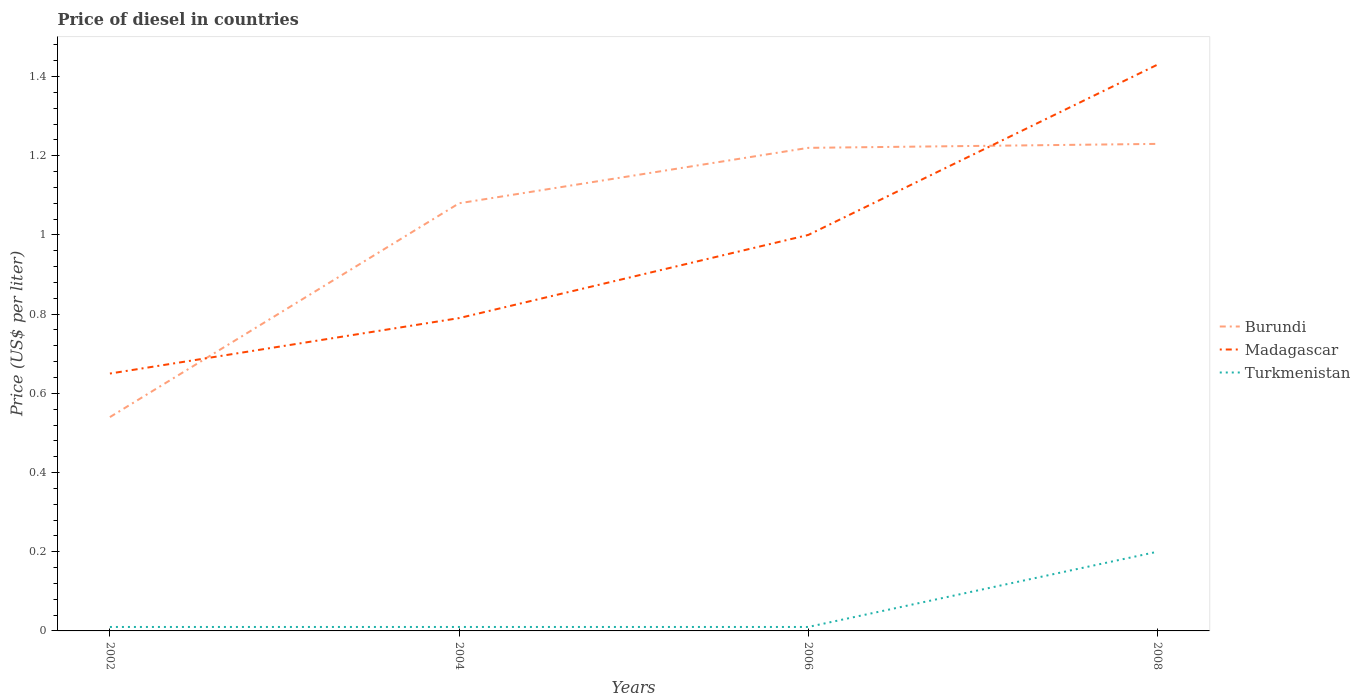Is the number of lines equal to the number of legend labels?
Provide a succinct answer. Yes. Across all years, what is the maximum price of diesel in Burundi?
Give a very brief answer. 0.54. In which year was the price of diesel in Madagascar maximum?
Make the answer very short. 2002. What is the total price of diesel in Burundi in the graph?
Offer a very short reply. -0.14. What is the difference between the highest and the second highest price of diesel in Burundi?
Make the answer very short. 0.69. What is the difference between the highest and the lowest price of diesel in Madagascar?
Offer a very short reply. 2. How many lines are there?
Ensure brevity in your answer.  3. How many years are there in the graph?
Offer a terse response. 4. Does the graph contain any zero values?
Provide a succinct answer. No. What is the title of the graph?
Offer a very short reply. Price of diesel in countries. What is the label or title of the Y-axis?
Your response must be concise. Price (US$ per liter). What is the Price (US$ per liter) in Burundi in 2002?
Keep it short and to the point. 0.54. What is the Price (US$ per liter) in Madagascar in 2002?
Provide a short and direct response. 0.65. What is the Price (US$ per liter) in Turkmenistan in 2002?
Ensure brevity in your answer.  0.01. What is the Price (US$ per liter) in Burundi in 2004?
Your response must be concise. 1.08. What is the Price (US$ per liter) in Madagascar in 2004?
Provide a short and direct response. 0.79. What is the Price (US$ per liter) in Turkmenistan in 2004?
Offer a terse response. 0.01. What is the Price (US$ per liter) of Burundi in 2006?
Give a very brief answer. 1.22. What is the Price (US$ per liter) of Madagascar in 2006?
Your response must be concise. 1. What is the Price (US$ per liter) in Burundi in 2008?
Your response must be concise. 1.23. What is the Price (US$ per liter) in Madagascar in 2008?
Give a very brief answer. 1.43. Across all years, what is the maximum Price (US$ per liter) in Burundi?
Offer a very short reply. 1.23. Across all years, what is the maximum Price (US$ per liter) in Madagascar?
Your response must be concise. 1.43. Across all years, what is the maximum Price (US$ per liter) in Turkmenistan?
Offer a terse response. 0.2. Across all years, what is the minimum Price (US$ per liter) of Burundi?
Provide a succinct answer. 0.54. Across all years, what is the minimum Price (US$ per liter) in Madagascar?
Offer a very short reply. 0.65. What is the total Price (US$ per liter) in Burundi in the graph?
Make the answer very short. 4.07. What is the total Price (US$ per liter) of Madagascar in the graph?
Ensure brevity in your answer.  3.87. What is the total Price (US$ per liter) of Turkmenistan in the graph?
Make the answer very short. 0.23. What is the difference between the Price (US$ per liter) in Burundi in 2002 and that in 2004?
Provide a short and direct response. -0.54. What is the difference between the Price (US$ per liter) of Madagascar in 2002 and that in 2004?
Keep it short and to the point. -0.14. What is the difference between the Price (US$ per liter) of Burundi in 2002 and that in 2006?
Your answer should be compact. -0.68. What is the difference between the Price (US$ per liter) of Madagascar in 2002 and that in 2006?
Make the answer very short. -0.35. What is the difference between the Price (US$ per liter) of Turkmenistan in 2002 and that in 2006?
Your response must be concise. 0. What is the difference between the Price (US$ per liter) in Burundi in 2002 and that in 2008?
Provide a succinct answer. -0.69. What is the difference between the Price (US$ per liter) in Madagascar in 2002 and that in 2008?
Your answer should be very brief. -0.78. What is the difference between the Price (US$ per liter) of Turkmenistan in 2002 and that in 2008?
Your answer should be very brief. -0.19. What is the difference between the Price (US$ per liter) in Burundi in 2004 and that in 2006?
Provide a succinct answer. -0.14. What is the difference between the Price (US$ per liter) of Madagascar in 2004 and that in 2006?
Your answer should be compact. -0.21. What is the difference between the Price (US$ per liter) of Turkmenistan in 2004 and that in 2006?
Your answer should be very brief. 0. What is the difference between the Price (US$ per liter) of Madagascar in 2004 and that in 2008?
Offer a very short reply. -0.64. What is the difference between the Price (US$ per liter) in Turkmenistan in 2004 and that in 2008?
Your answer should be very brief. -0.19. What is the difference between the Price (US$ per liter) of Burundi in 2006 and that in 2008?
Offer a very short reply. -0.01. What is the difference between the Price (US$ per liter) in Madagascar in 2006 and that in 2008?
Give a very brief answer. -0.43. What is the difference between the Price (US$ per liter) in Turkmenistan in 2006 and that in 2008?
Your answer should be compact. -0.19. What is the difference between the Price (US$ per liter) in Burundi in 2002 and the Price (US$ per liter) in Turkmenistan in 2004?
Your answer should be compact. 0.53. What is the difference between the Price (US$ per liter) of Madagascar in 2002 and the Price (US$ per liter) of Turkmenistan in 2004?
Your answer should be compact. 0.64. What is the difference between the Price (US$ per liter) of Burundi in 2002 and the Price (US$ per liter) of Madagascar in 2006?
Your answer should be very brief. -0.46. What is the difference between the Price (US$ per liter) of Burundi in 2002 and the Price (US$ per liter) of Turkmenistan in 2006?
Offer a terse response. 0.53. What is the difference between the Price (US$ per liter) of Madagascar in 2002 and the Price (US$ per liter) of Turkmenistan in 2006?
Give a very brief answer. 0.64. What is the difference between the Price (US$ per liter) of Burundi in 2002 and the Price (US$ per liter) of Madagascar in 2008?
Your answer should be compact. -0.89. What is the difference between the Price (US$ per liter) of Burundi in 2002 and the Price (US$ per liter) of Turkmenistan in 2008?
Provide a succinct answer. 0.34. What is the difference between the Price (US$ per liter) in Madagascar in 2002 and the Price (US$ per liter) in Turkmenistan in 2008?
Offer a very short reply. 0.45. What is the difference between the Price (US$ per liter) in Burundi in 2004 and the Price (US$ per liter) in Madagascar in 2006?
Keep it short and to the point. 0.08. What is the difference between the Price (US$ per liter) of Burundi in 2004 and the Price (US$ per liter) of Turkmenistan in 2006?
Provide a succinct answer. 1.07. What is the difference between the Price (US$ per liter) in Madagascar in 2004 and the Price (US$ per liter) in Turkmenistan in 2006?
Provide a succinct answer. 0.78. What is the difference between the Price (US$ per liter) in Burundi in 2004 and the Price (US$ per liter) in Madagascar in 2008?
Your answer should be very brief. -0.35. What is the difference between the Price (US$ per liter) in Burundi in 2004 and the Price (US$ per liter) in Turkmenistan in 2008?
Keep it short and to the point. 0.88. What is the difference between the Price (US$ per liter) in Madagascar in 2004 and the Price (US$ per liter) in Turkmenistan in 2008?
Give a very brief answer. 0.59. What is the difference between the Price (US$ per liter) in Burundi in 2006 and the Price (US$ per liter) in Madagascar in 2008?
Ensure brevity in your answer.  -0.21. What is the difference between the Price (US$ per liter) in Burundi in 2006 and the Price (US$ per liter) in Turkmenistan in 2008?
Give a very brief answer. 1.02. What is the difference between the Price (US$ per liter) in Madagascar in 2006 and the Price (US$ per liter) in Turkmenistan in 2008?
Provide a short and direct response. 0.8. What is the average Price (US$ per liter) in Burundi per year?
Provide a succinct answer. 1.02. What is the average Price (US$ per liter) of Madagascar per year?
Offer a terse response. 0.97. What is the average Price (US$ per liter) of Turkmenistan per year?
Ensure brevity in your answer.  0.06. In the year 2002, what is the difference between the Price (US$ per liter) of Burundi and Price (US$ per liter) of Madagascar?
Offer a very short reply. -0.11. In the year 2002, what is the difference between the Price (US$ per liter) in Burundi and Price (US$ per liter) in Turkmenistan?
Give a very brief answer. 0.53. In the year 2002, what is the difference between the Price (US$ per liter) in Madagascar and Price (US$ per liter) in Turkmenistan?
Offer a very short reply. 0.64. In the year 2004, what is the difference between the Price (US$ per liter) in Burundi and Price (US$ per liter) in Madagascar?
Your answer should be compact. 0.29. In the year 2004, what is the difference between the Price (US$ per liter) in Burundi and Price (US$ per liter) in Turkmenistan?
Provide a short and direct response. 1.07. In the year 2004, what is the difference between the Price (US$ per liter) of Madagascar and Price (US$ per liter) of Turkmenistan?
Offer a very short reply. 0.78. In the year 2006, what is the difference between the Price (US$ per liter) of Burundi and Price (US$ per liter) of Madagascar?
Offer a very short reply. 0.22. In the year 2006, what is the difference between the Price (US$ per liter) of Burundi and Price (US$ per liter) of Turkmenistan?
Your response must be concise. 1.21. In the year 2008, what is the difference between the Price (US$ per liter) in Burundi and Price (US$ per liter) in Madagascar?
Provide a succinct answer. -0.2. In the year 2008, what is the difference between the Price (US$ per liter) of Madagascar and Price (US$ per liter) of Turkmenistan?
Keep it short and to the point. 1.23. What is the ratio of the Price (US$ per liter) in Burundi in 2002 to that in 2004?
Offer a terse response. 0.5. What is the ratio of the Price (US$ per liter) of Madagascar in 2002 to that in 2004?
Keep it short and to the point. 0.82. What is the ratio of the Price (US$ per liter) of Turkmenistan in 2002 to that in 2004?
Ensure brevity in your answer.  1. What is the ratio of the Price (US$ per liter) of Burundi in 2002 to that in 2006?
Make the answer very short. 0.44. What is the ratio of the Price (US$ per liter) in Madagascar in 2002 to that in 2006?
Offer a very short reply. 0.65. What is the ratio of the Price (US$ per liter) in Burundi in 2002 to that in 2008?
Provide a succinct answer. 0.44. What is the ratio of the Price (US$ per liter) in Madagascar in 2002 to that in 2008?
Provide a succinct answer. 0.45. What is the ratio of the Price (US$ per liter) of Turkmenistan in 2002 to that in 2008?
Provide a succinct answer. 0.05. What is the ratio of the Price (US$ per liter) of Burundi in 2004 to that in 2006?
Provide a succinct answer. 0.89. What is the ratio of the Price (US$ per liter) in Madagascar in 2004 to that in 2006?
Offer a very short reply. 0.79. What is the ratio of the Price (US$ per liter) in Burundi in 2004 to that in 2008?
Offer a terse response. 0.88. What is the ratio of the Price (US$ per liter) of Madagascar in 2004 to that in 2008?
Keep it short and to the point. 0.55. What is the ratio of the Price (US$ per liter) in Turkmenistan in 2004 to that in 2008?
Your response must be concise. 0.05. What is the ratio of the Price (US$ per liter) of Madagascar in 2006 to that in 2008?
Your answer should be very brief. 0.7. What is the difference between the highest and the second highest Price (US$ per liter) of Burundi?
Provide a succinct answer. 0.01. What is the difference between the highest and the second highest Price (US$ per liter) of Madagascar?
Give a very brief answer. 0.43. What is the difference between the highest and the second highest Price (US$ per liter) in Turkmenistan?
Offer a very short reply. 0.19. What is the difference between the highest and the lowest Price (US$ per liter) of Burundi?
Your answer should be very brief. 0.69. What is the difference between the highest and the lowest Price (US$ per liter) of Madagascar?
Provide a short and direct response. 0.78. What is the difference between the highest and the lowest Price (US$ per liter) of Turkmenistan?
Offer a terse response. 0.19. 